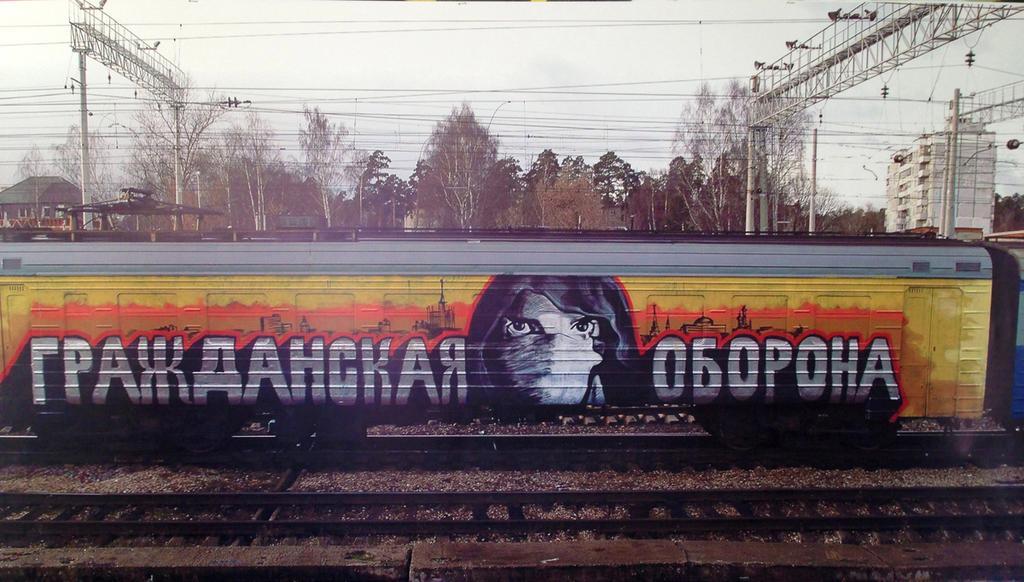Could you give a brief overview of what you see in this image? Here in this picture we can see a train present on the railway track over there and on that we can see some paintings done and we can also see other tracks present over there and behind that we can see electric poles and trees present all over there and in the far we can see some houses also present over there. 